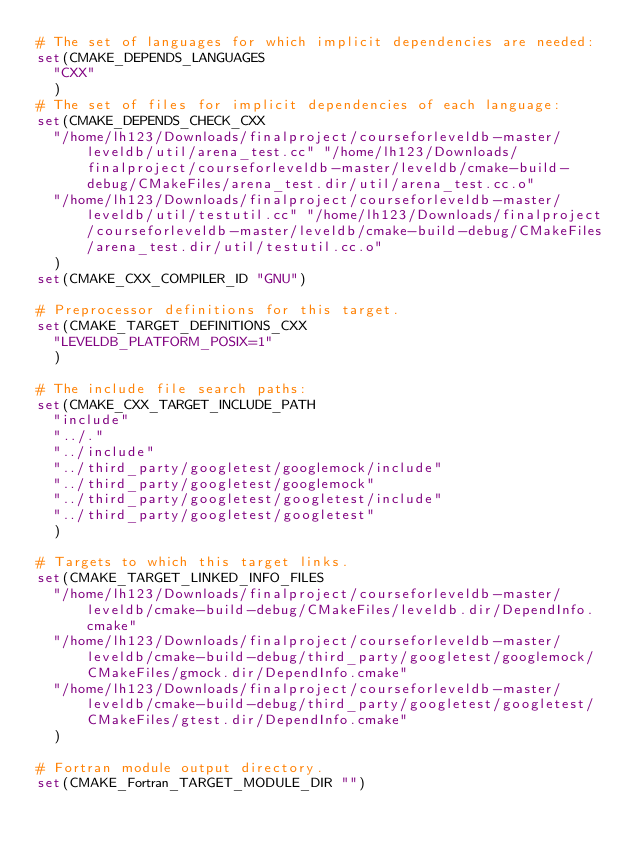<code> <loc_0><loc_0><loc_500><loc_500><_CMake_># The set of languages for which implicit dependencies are needed:
set(CMAKE_DEPENDS_LANGUAGES
  "CXX"
  )
# The set of files for implicit dependencies of each language:
set(CMAKE_DEPENDS_CHECK_CXX
  "/home/lh123/Downloads/finalproject/courseforleveldb-master/leveldb/util/arena_test.cc" "/home/lh123/Downloads/finalproject/courseforleveldb-master/leveldb/cmake-build-debug/CMakeFiles/arena_test.dir/util/arena_test.cc.o"
  "/home/lh123/Downloads/finalproject/courseforleveldb-master/leveldb/util/testutil.cc" "/home/lh123/Downloads/finalproject/courseforleveldb-master/leveldb/cmake-build-debug/CMakeFiles/arena_test.dir/util/testutil.cc.o"
  )
set(CMAKE_CXX_COMPILER_ID "GNU")

# Preprocessor definitions for this target.
set(CMAKE_TARGET_DEFINITIONS_CXX
  "LEVELDB_PLATFORM_POSIX=1"
  )

# The include file search paths:
set(CMAKE_CXX_TARGET_INCLUDE_PATH
  "include"
  "../."
  "../include"
  "../third_party/googletest/googlemock/include"
  "../third_party/googletest/googlemock"
  "../third_party/googletest/googletest/include"
  "../third_party/googletest/googletest"
  )

# Targets to which this target links.
set(CMAKE_TARGET_LINKED_INFO_FILES
  "/home/lh123/Downloads/finalproject/courseforleveldb-master/leveldb/cmake-build-debug/CMakeFiles/leveldb.dir/DependInfo.cmake"
  "/home/lh123/Downloads/finalproject/courseforleveldb-master/leveldb/cmake-build-debug/third_party/googletest/googlemock/CMakeFiles/gmock.dir/DependInfo.cmake"
  "/home/lh123/Downloads/finalproject/courseforleveldb-master/leveldb/cmake-build-debug/third_party/googletest/googletest/CMakeFiles/gtest.dir/DependInfo.cmake"
  )

# Fortran module output directory.
set(CMAKE_Fortran_TARGET_MODULE_DIR "")
</code> 